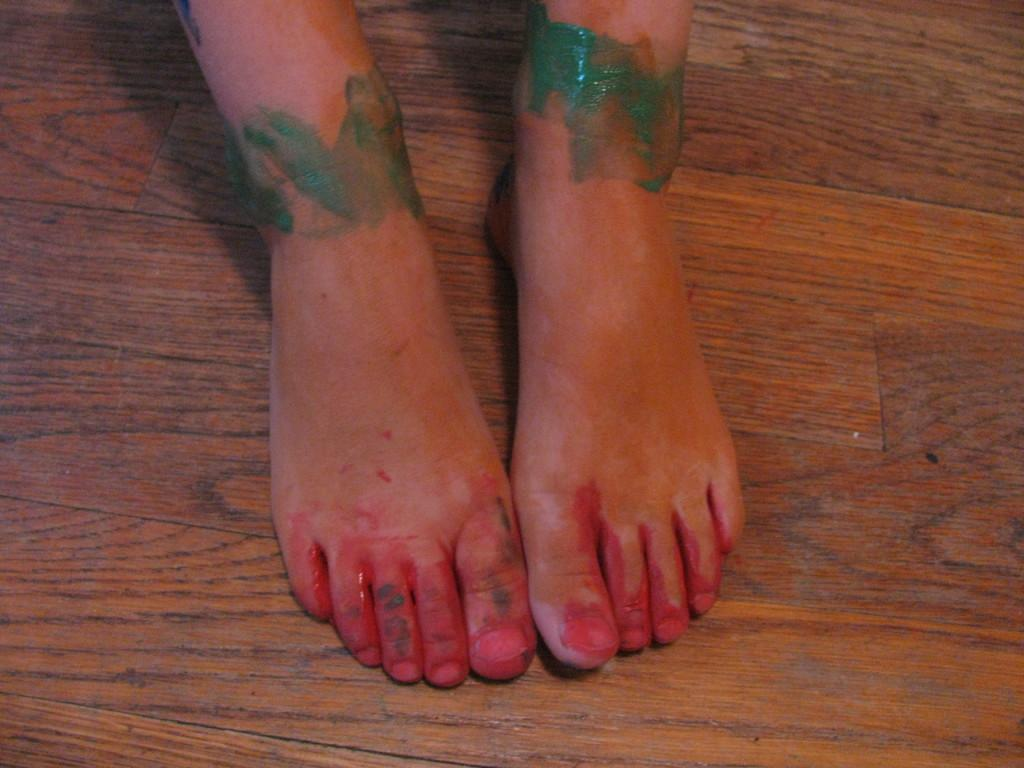What part of a person's body is visible in the image? There are legs of a person visible in the image. What type of surface is the person's legs resting on? The legs are on a wooden surface. What type of lock is present on the person's legs in the image? There is no lock present on the person's legs in the image. What key is used to unlock the lock on the person's legs in the image? There is no lock or key present on the person's legs in the image. 